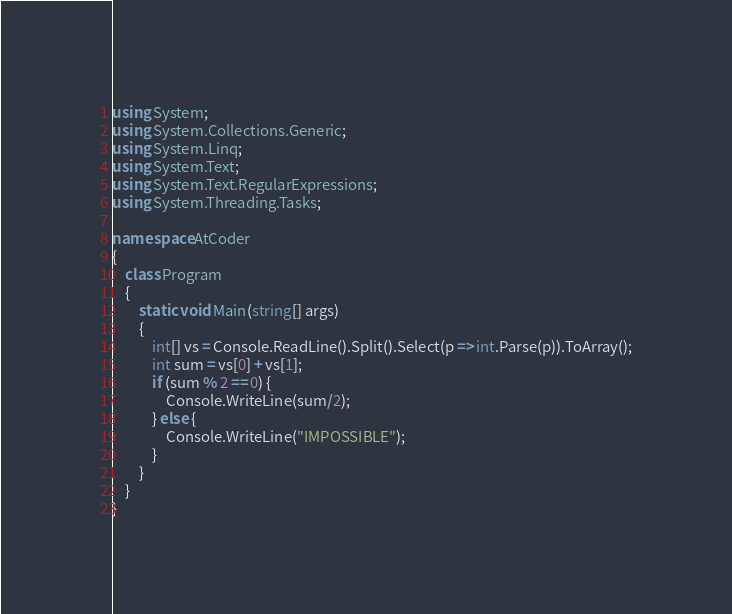<code> <loc_0><loc_0><loc_500><loc_500><_C#_>using System;
using System.Collections.Generic;
using System.Linq;
using System.Text;
using System.Text.RegularExpressions;
using System.Threading.Tasks;

namespace AtCoder
{
	class Program
	{
		static void Main(string[] args)
		{
            int[] vs = Console.ReadLine().Split().Select(p => int.Parse(p)).ToArray();
            int sum = vs[0] + vs[1];
            if (sum % 2 == 0) {
                Console.WriteLine(sum/2);
            } else {
                Console.WriteLine("IMPOSSIBLE");
            }
        }
    }
}
</code> 